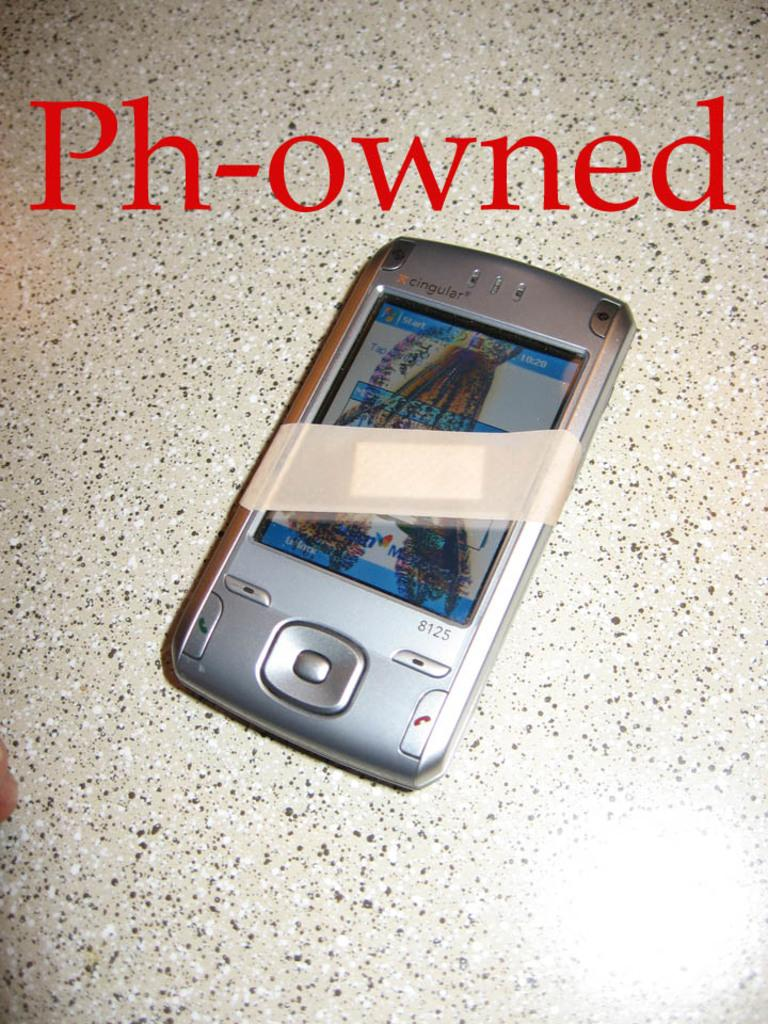<image>
Write a terse but informative summary of the picture. A phone with a bandage on it with letters on top saying Ph-owned 